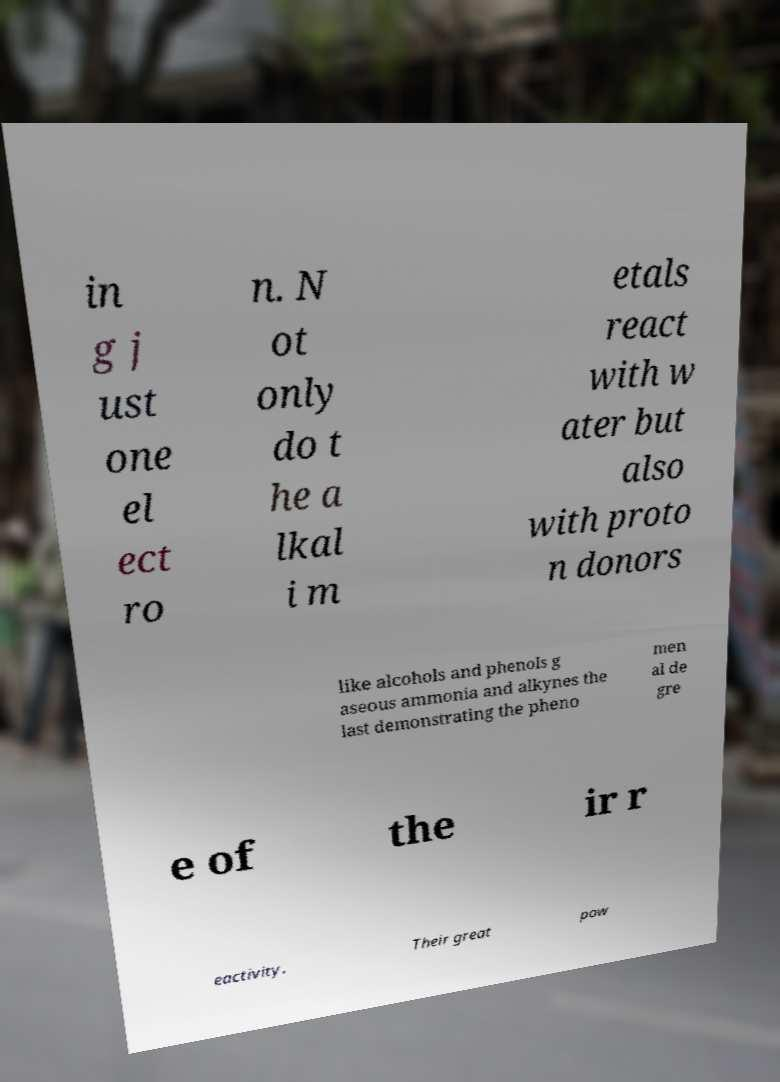Can you accurately transcribe the text from the provided image for me? in g j ust one el ect ro n. N ot only do t he a lkal i m etals react with w ater but also with proto n donors like alcohols and phenols g aseous ammonia and alkynes the last demonstrating the pheno men al de gre e of the ir r eactivity. Their great pow 